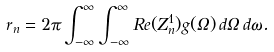<formula> <loc_0><loc_0><loc_500><loc_500>r _ { n } = 2 \pi \int _ { - \infty } ^ { \infty } \int _ { - \infty } ^ { \infty } R e ( Z _ { n } ^ { 1 } ) g ( \Omega ) \, d \Omega \, d \omega .</formula> 